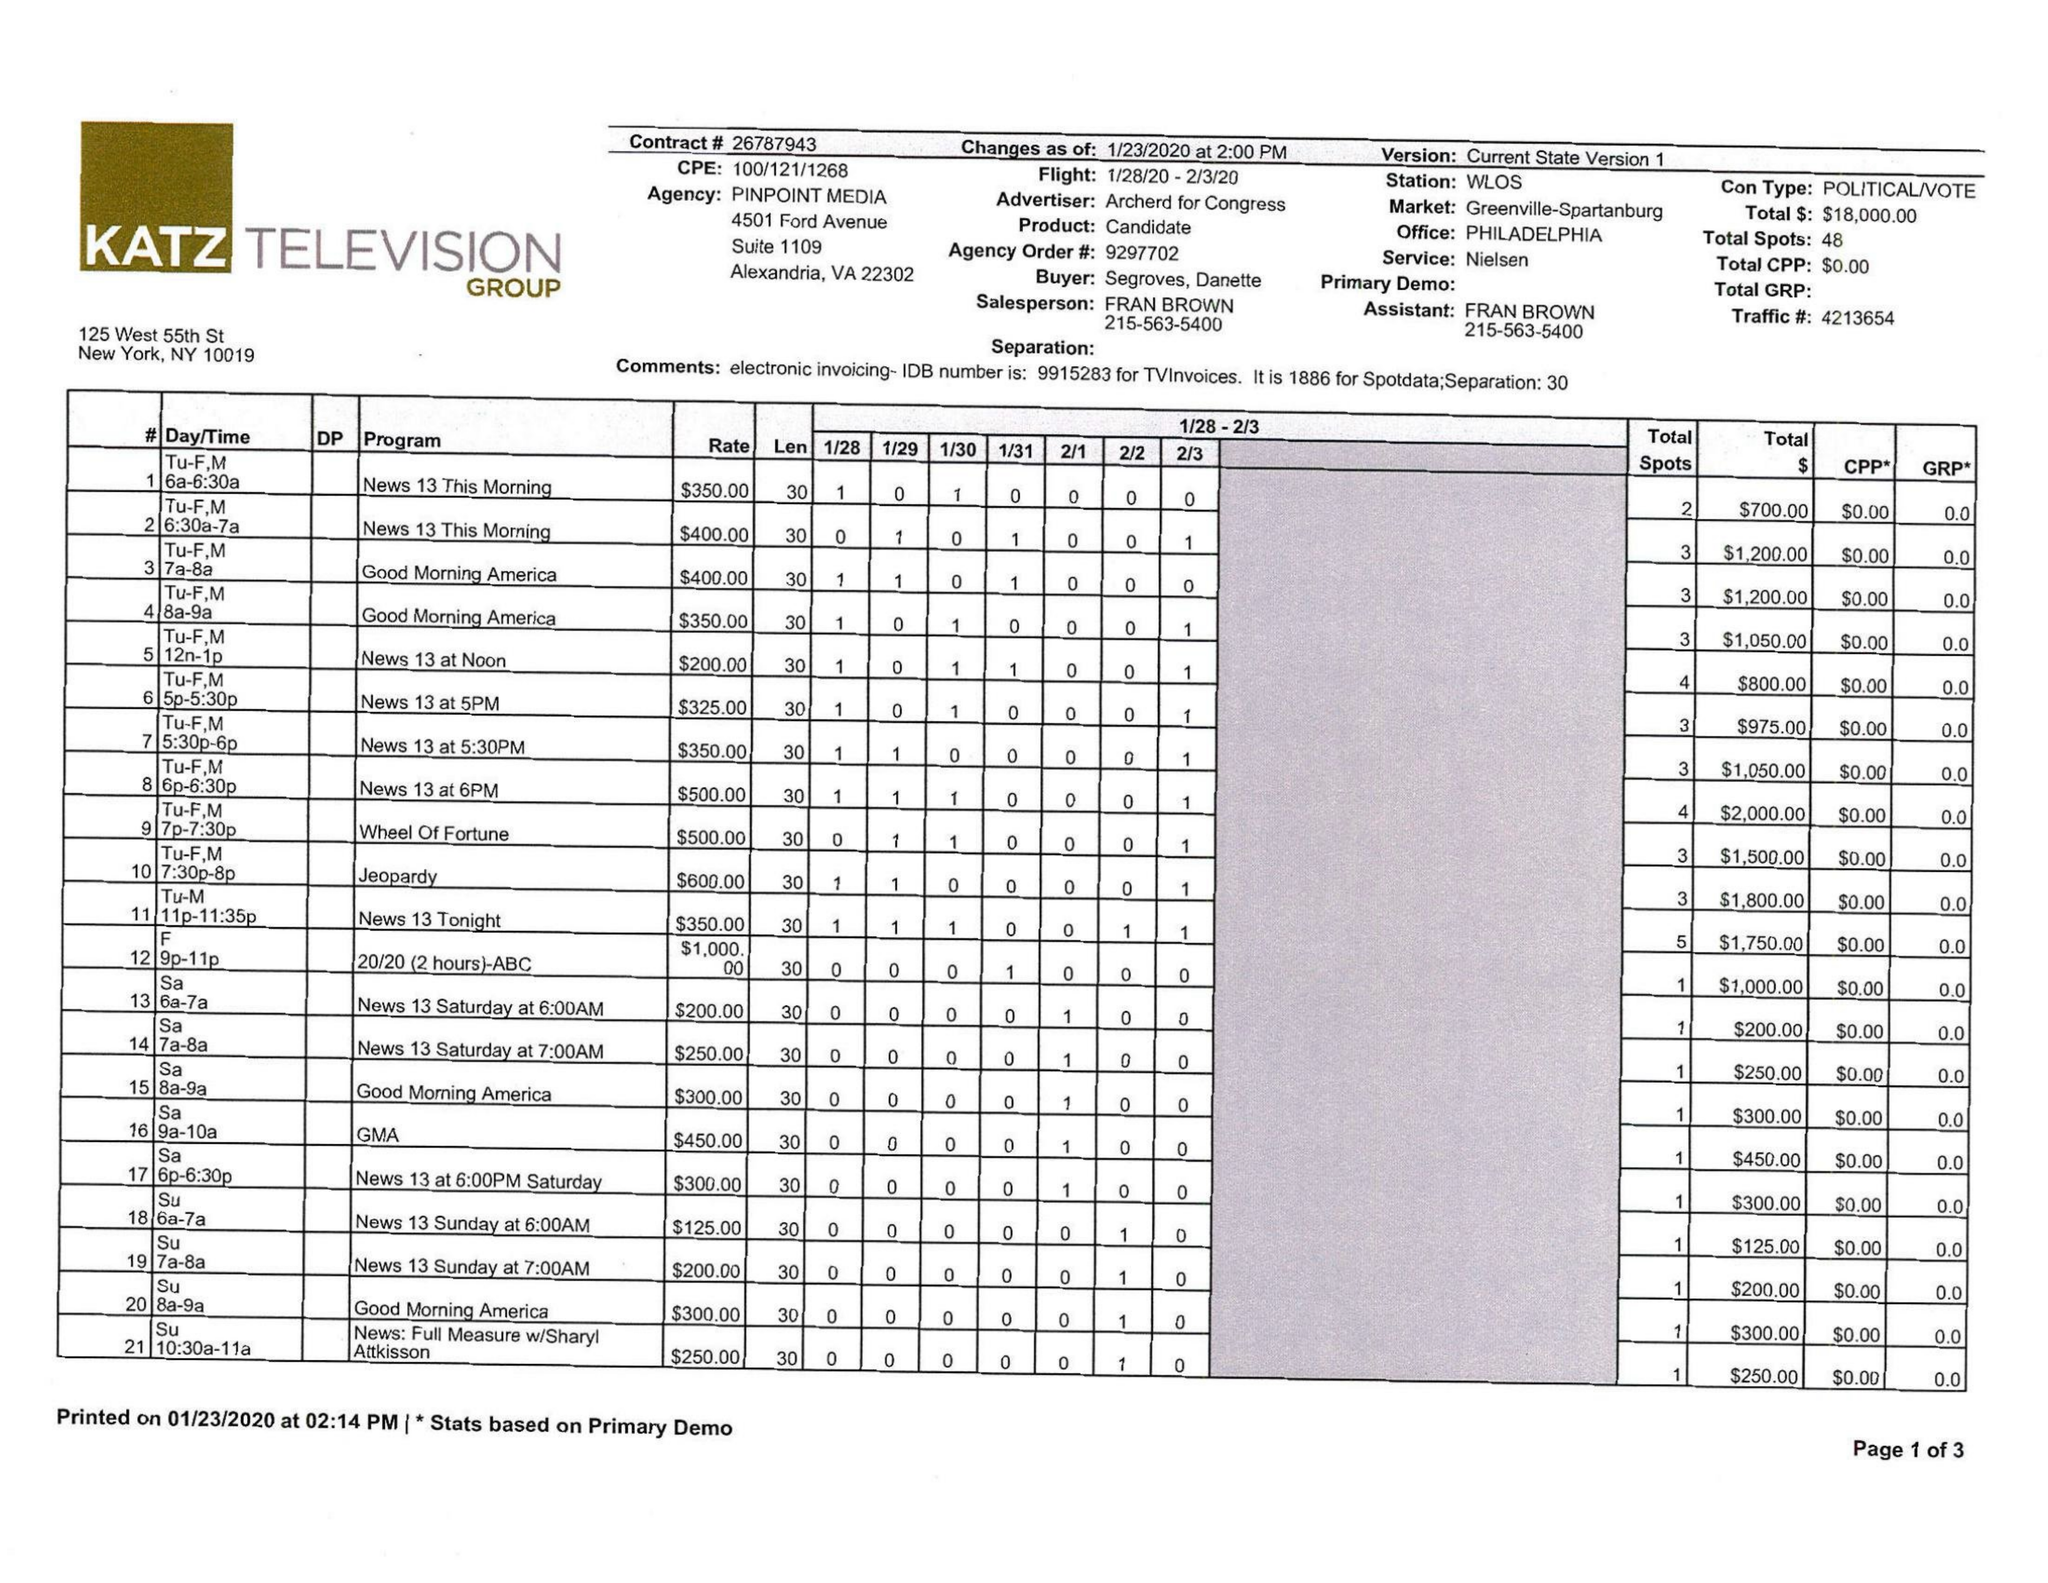What is the value for the flight_from?
Answer the question using a single word or phrase. 01/28/20 